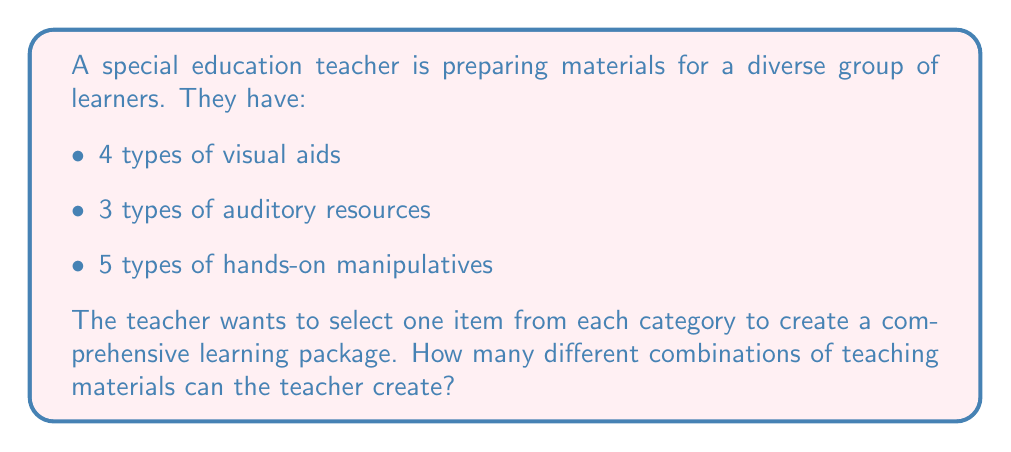Can you solve this math problem? Let's approach this step-by-step using the multiplication principle of counting:

1) For each learning package, the teacher needs to make three independent choices:
   - One choice from the visual aids
   - One choice from the auditory resources
   - One choice from the hands-on manipulatives

2) For each of these choices:
   - There are 4 options for visual aids
   - There are 3 options for auditory resources
   - There are 5 options for hands-on manipulatives

3) According to the multiplication principle, when we have a sequence of independent choices, we multiply the number of options for each choice:

   $$ \text{Total combinations} = 4 \times 3 \times 5 $$

4) Calculating this:
   $$ 4 \times 3 \times 5 = 12 \times 5 = 60 $$

Therefore, the teacher can create 60 different combinations of teaching materials.
Answer: 60 